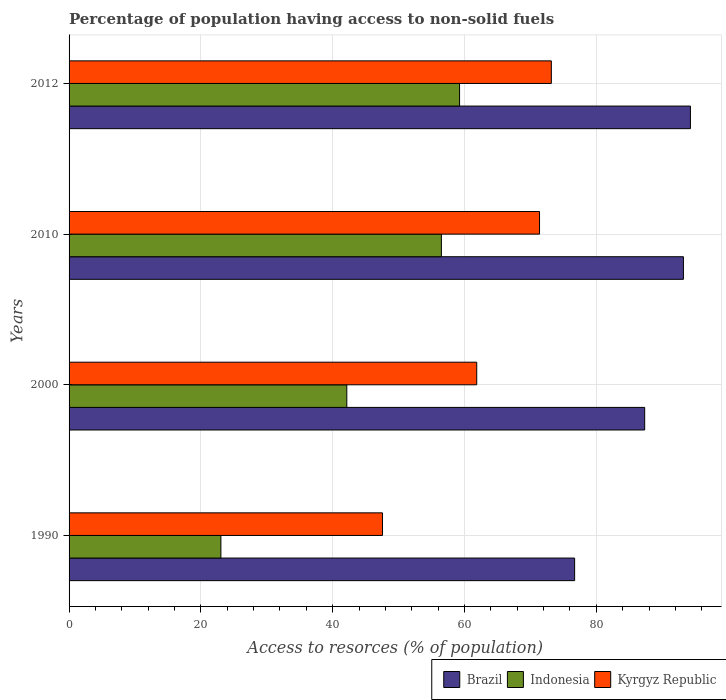Are the number of bars per tick equal to the number of legend labels?
Your response must be concise. Yes. How many bars are there on the 2nd tick from the top?
Give a very brief answer. 3. What is the percentage of population having access to non-solid fuels in Kyrgyz Republic in 1990?
Your answer should be compact. 47.55. Across all years, what is the maximum percentage of population having access to non-solid fuels in Brazil?
Keep it short and to the point. 94.28. Across all years, what is the minimum percentage of population having access to non-solid fuels in Brazil?
Keep it short and to the point. 76.71. In which year was the percentage of population having access to non-solid fuels in Kyrgyz Republic maximum?
Ensure brevity in your answer.  2012. What is the total percentage of population having access to non-solid fuels in Kyrgyz Republic in the graph?
Give a very brief answer. 253.97. What is the difference between the percentage of population having access to non-solid fuels in Brazil in 2000 and that in 2012?
Offer a terse response. -6.94. What is the difference between the percentage of population having access to non-solid fuels in Indonesia in 1990 and the percentage of population having access to non-solid fuels in Brazil in 2000?
Provide a succinct answer. -64.3. What is the average percentage of population having access to non-solid fuels in Indonesia per year?
Your answer should be compact. 45.23. In the year 1990, what is the difference between the percentage of population having access to non-solid fuels in Indonesia and percentage of population having access to non-solid fuels in Brazil?
Make the answer very short. -53.67. What is the ratio of the percentage of population having access to non-solid fuels in Kyrgyz Republic in 1990 to that in 2000?
Offer a very short reply. 0.77. What is the difference between the highest and the second highest percentage of population having access to non-solid fuels in Kyrgyz Republic?
Offer a very short reply. 1.79. What is the difference between the highest and the lowest percentage of population having access to non-solid fuels in Brazil?
Your answer should be very brief. 17.57. In how many years, is the percentage of population having access to non-solid fuels in Kyrgyz Republic greater than the average percentage of population having access to non-solid fuels in Kyrgyz Republic taken over all years?
Offer a very short reply. 2. What does the 3rd bar from the top in 2012 represents?
Offer a very short reply. Brazil. Is it the case that in every year, the sum of the percentage of population having access to non-solid fuels in Indonesia and percentage of population having access to non-solid fuels in Kyrgyz Republic is greater than the percentage of population having access to non-solid fuels in Brazil?
Keep it short and to the point. No. Are the values on the major ticks of X-axis written in scientific E-notation?
Your answer should be compact. No. Does the graph contain grids?
Your answer should be very brief. Yes. How many legend labels are there?
Keep it short and to the point. 3. How are the legend labels stacked?
Ensure brevity in your answer.  Horizontal. What is the title of the graph?
Provide a succinct answer. Percentage of population having access to non-solid fuels. Does "Canada" appear as one of the legend labels in the graph?
Your answer should be compact. No. What is the label or title of the X-axis?
Your response must be concise. Access to resorces (% of population). What is the Access to resorces (% of population) in Brazil in 1990?
Keep it short and to the point. 76.71. What is the Access to resorces (% of population) in Indonesia in 1990?
Ensure brevity in your answer.  23.04. What is the Access to resorces (% of population) in Kyrgyz Republic in 1990?
Your answer should be very brief. 47.55. What is the Access to resorces (% of population) in Brazil in 2000?
Your answer should be compact. 87.34. What is the Access to resorces (% of population) of Indonesia in 2000?
Your response must be concise. 42.14. What is the Access to resorces (% of population) of Kyrgyz Republic in 2000?
Your response must be concise. 61.85. What is the Access to resorces (% of population) of Brazil in 2010?
Ensure brevity in your answer.  93.22. What is the Access to resorces (% of population) of Indonesia in 2010?
Keep it short and to the point. 56.49. What is the Access to resorces (% of population) in Kyrgyz Republic in 2010?
Provide a succinct answer. 71.38. What is the Access to resorces (% of population) of Brazil in 2012?
Your answer should be compact. 94.28. What is the Access to resorces (% of population) in Indonesia in 2012?
Your response must be concise. 59.25. What is the Access to resorces (% of population) of Kyrgyz Republic in 2012?
Ensure brevity in your answer.  73.18. Across all years, what is the maximum Access to resorces (% of population) of Brazil?
Offer a very short reply. 94.28. Across all years, what is the maximum Access to resorces (% of population) in Indonesia?
Offer a terse response. 59.25. Across all years, what is the maximum Access to resorces (% of population) in Kyrgyz Republic?
Ensure brevity in your answer.  73.18. Across all years, what is the minimum Access to resorces (% of population) of Brazil?
Make the answer very short. 76.71. Across all years, what is the minimum Access to resorces (% of population) in Indonesia?
Provide a short and direct response. 23.04. Across all years, what is the minimum Access to resorces (% of population) in Kyrgyz Republic?
Make the answer very short. 47.55. What is the total Access to resorces (% of population) in Brazil in the graph?
Provide a short and direct response. 351.54. What is the total Access to resorces (% of population) in Indonesia in the graph?
Your answer should be very brief. 180.92. What is the total Access to resorces (% of population) of Kyrgyz Republic in the graph?
Your response must be concise. 253.97. What is the difference between the Access to resorces (% of population) of Brazil in 1990 and that in 2000?
Your answer should be compact. -10.63. What is the difference between the Access to resorces (% of population) in Indonesia in 1990 and that in 2000?
Your answer should be compact. -19.11. What is the difference between the Access to resorces (% of population) of Kyrgyz Republic in 1990 and that in 2000?
Provide a short and direct response. -14.3. What is the difference between the Access to resorces (% of population) in Brazil in 1990 and that in 2010?
Offer a very short reply. -16.51. What is the difference between the Access to resorces (% of population) of Indonesia in 1990 and that in 2010?
Offer a terse response. -33.46. What is the difference between the Access to resorces (% of population) of Kyrgyz Republic in 1990 and that in 2010?
Give a very brief answer. -23.83. What is the difference between the Access to resorces (% of population) in Brazil in 1990 and that in 2012?
Make the answer very short. -17.57. What is the difference between the Access to resorces (% of population) in Indonesia in 1990 and that in 2012?
Provide a short and direct response. -36.21. What is the difference between the Access to resorces (% of population) of Kyrgyz Republic in 1990 and that in 2012?
Give a very brief answer. -25.62. What is the difference between the Access to resorces (% of population) of Brazil in 2000 and that in 2010?
Your response must be concise. -5.88. What is the difference between the Access to resorces (% of population) in Indonesia in 2000 and that in 2010?
Give a very brief answer. -14.35. What is the difference between the Access to resorces (% of population) of Kyrgyz Republic in 2000 and that in 2010?
Your response must be concise. -9.53. What is the difference between the Access to resorces (% of population) of Brazil in 2000 and that in 2012?
Ensure brevity in your answer.  -6.94. What is the difference between the Access to resorces (% of population) of Indonesia in 2000 and that in 2012?
Provide a short and direct response. -17.11. What is the difference between the Access to resorces (% of population) in Kyrgyz Republic in 2000 and that in 2012?
Offer a very short reply. -11.32. What is the difference between the Access to resorces (% of population) of Brazil in 2010 and that in 2012?
Offer a terse response. -1.06. What is the difference between the Access to resorces (% of population) of Indonesia in 2010 and that in 2012?
Provide a short and direct response. -2.76. What is the difference between the Access to resorces (% of population) in Kyrgyz Republic in 2010 and that in 2012?
Give a very brief answer. -1.79. What is the difference between the Access to resorces (% of population) of Brazil in 1990 and the Access to resorces (% of population) of Indonesia in 2000?
Make the answer very short. 34.57. What is the difference between the Access to resorces (% of population) in Brazil in 1990 and the Access to resorces (% of population) in Kyrgyz Republic in 2000?
Give a very brief answer. 14.85. What is the difference between the Access to resorces (% of population) in Indonesia in 1990 and the Access to resorces (% of population) in Kyrgyz Republic in 2000?
Give a very brief answer. -38.82. What is the difference between the Access to resorces (% of population) of Brazil in 1990 and the Access to resorces (% of population) of Indonesia in 2010?
Offer a very short reply. 20.21. What is the difference between the Access to resorces (% of population) of Brazil in 1990 and the Access to resorces (% of population) of Kyrgyz Republic in 2010?
Offer a terse response. 5.32. What is the difference between the Access to resorces (% of population) of Indonesia in 1990 and the Access to resorces (% of population) of Kyrgyz Republic in 2010?
Offer a terse response. -48.35. What is the difference between the Access to resorces (% of population) in Brazil in 1990 and the Access to resorces (% of population) in Indonesia in 2012?
Keep it short and to the point. 17.46. What is the difference between the Access to resorces (% of population) of Brazil in 1990 and the Access to resorces (% of population) of Kyrgyz Republic in 2012?
Ensure brevity in your answer.  3.53. What is the difference between the Access to resorces (% of population) of Indonesia in 1990 and the Access to resorces (% of population) of Kyrgyz Republic in 2012?
Your answer should be very brief. -50.14. What is the difference between the Access to resorces (% of population) in Brazil in 2000 and the Access to resorces (% of population) in Indonesia in 2010?
Your response must be concise. 30.85. What is the difference between the Access to resorces (% of population) in Brazil in 2000 and the Access to resorces (% of population) in Kyrgyz Republic in 2010?
Keep it short and to the point. 15.96. What is the difference between the Access to resorces (% of population) in Indonesia in 2000 and the Access to resorces (% of population) in Kyrgyz Republic in 2010?
Keep it short and to the point. -29.24. What is the difference between the Access to resorces (% of population) of Brazil in 2000 and the Access to resorces (% of population) of Indonesia in 2012?
Give a very brief answer. 28.09. What is the difference between the Access to resorces (% of population) in Brazil in 2000 and the Access to resorces (% of population) in Kyrgyz Republic in 2012?
Your response must be concise. 14.16. What is the difference between the Access to resorces (% of population) of Indonesia in 2000 and the Access to resorces (% of population) of Kyrgyz Republic in 2012?
Make the answer very short. -31.03. What is the difference between the Access to resorces (% of population) in Brazil in 2010 and the Access to resorces (% of population) in Indonesia in 2012?
Your answer should be compact. 33.97. What is the difference between the Access to resorces (% of population) of Brazil in 2010 and the Access to resorces (% of population) of Kyrgyz Republic in 2012?
Offer a very short reply. 20.04. What is the difference between the Access to resorces (% of population) in Indonesia in 2010 and the Access to resorces (% of population) in Kyrgyz Republic in 2012?
Ensure brevity in your answer.  -16.68. What is the average Access to resorces (% of population) in Brazil per year?
Make the answer very short. 87.89. What is the average Access to resorces (% of population) in Indonesia per year?
Offer a very short reply. 45.23. What is the average Access to resorces (% of population) in Kyrgyz Republic per year?
Offer a terse response. 63.49. In the year 1990, what is the difference between the Access to resorces (% of population) in Brazil and Access to resorces (% of population) in Indonesia?
Provide a short and direct response. 53.67. In the year 1990, what is the difference between the Access to resorces (% of population) in Brazil and Access to resorces (% of population) in Kyrgyz Republic?
Provide a short and direct response. 29.15. In the year 1990, what is the difference between the Access to resorces (% of population) of Indonesia and Access to resorces (% of population) of Kyrgyz Republic?
Make the answer very short. -24.52. In the year 2000, what is the difference between the Access to resorces (% of population) in Brazil and Access to resorces (% of population) in Indonesia?
Offer a very short reply. 45.2. In the year 2000, what is the difference between the Access to resorces (% of population) in Brazil and Access to resorces (% of population) in Kyrgyz Republic?
Ensure brevity in your answer.  25.49. In the year 2000, what is the difference between the Access to resorces (% of population) of Indonesia and Access to resorces (% of population) of Kyrgyz Republic?
Your answer should be compact. -19.71. In the year 2010, what is the difference between the Access to resorces (% of population) of Brazil and Access to resorces (% of population) of Indonesia?
Your answer should be compact. 36.72. In the year 2010, what is the difference between the Access to resorces (% of population) in Brazil and Access to resorces (% of population) in Kyrgyz Republic?
Your response must be concise. 21.83. In the year 2010, what is the difference between the Access to resorces (% of population) of Indonesia and Access to resorces (% of population) of Kyrgyz Republic?
Keep it short and to the point. -14.89. In the year 2012, what is the difference between the Access to resorces (% of population) of Brazil and Access to resorces (% of population) of Indonesia?
Provide a succinct answer. 35.03. In the year 2012, what is the difference between the Access to resorces (% of population) in Brazil and Access to resorces (% of population) in Kyrgyz Republic?
Provide a succinct answer. 21.1. In the year 2012, what is the difference between the Access to resorces (% of population) in Indonesia and Access to resorces (% of population) in Kyrgyz Republic?
Offer a very short reply. -13.93. What is the ratio of the Access to resorces (% of population) in Brazil in 1990 to that in 2000?
Keep it short and to the point. 0.88. What is the ratio of the Access to resorces (% of population) in Indonesia in 1990 to that in 2000?
Your answer should be very brief. 0.55. What is the ratio of the Access to resorces (% of population) of Kyrgyz Republic in 1990 to that in 2000?
Offer a very short reply. 0.77. What is the ratio of the Access to resorces (% of population) of Brazil in 1990 to that in 2010?
Keep it short and to the point. 0.82. What is the ratio of the Access to resorces (% of population) in Indonesia in 1990 to that in 2010?
Your answer should be very brief. 0.41. What is the ratio of the Access to resorces (% of population) of Kyrgyz Republic in 1990 to that in 2010?
Keep it short and to the point. 0.67. What is the ratio of the Access to resorces (% of population) in Brazil in 1990 to that in 2012?
Your answer should be very brief. 0.81. What is the ratio of the Access to resorces (% of population) of Indonesia in 1990 to that in 2012?
Your answer should be very brief. 0.39. What is the ratio of the Access to resorces (% of population) of Kyrgyz Republic in 1990 to that in 2012?
Make the answer very short. 0.65. What is the ratio of the Access to resorces (% of population) in Brazil in 2000 to that in 2010?
Give a very brief answer. 0.94. What is the ratio of the Access to resorces (% of population) in Indonesia in 2000 to that in 2010?
Ensure brevity in your answer.  0.75. What is the ratio of the Access to resorces (% of population) in Kyrgyz Republic in 2000 to that in 2010?
Your answer should be compact. 0.87. What is the ratio of the Access to resorces (% of population) of Brazil in 2000 to that in 2012?
Provide a succinct answer. 0.93. What is the ratio of the Access to resorces (% of population) in Indonesia in 2000 to that in 2012?
Ensure brevity in your answer.  0.71. What is the ratio of the Access to resorces (% of population) in Kyrgyz Republic in 2000 to that in 2012?
Your response must be concise. 0.85. What is the ratio of the Access to resorces (% of population) in Brazil in 2010 to that in 2012?
Keep it short and to the point. 0.99. What is the ratio of the Access to resorces (% of population) of Indonesia in 2010 to that in 2012?
Your answer should be very brief. 0.95. What is the ratio of the Access to resorces (% of population) of Kyrgyz Republic in 2010 to that in 2012?
Offer a terse response. 0.98. What is the difference between the highest and the second highest Access to resorces (% of population) in Brazil?
Provide a short and direct response. 1.06. What is the difference between the highest and the second highest Access to resorces (% of population) in Indonesia?
Your answer should be compact. 2.76. What is the difference between the highest and the second highest Access to resorces (% of population) in Kyrgyz Republic?
Make the answer very short. 1.79. What is the difference between the highest and the lowest Access to resorces (% of population) in Brazil?
Offer a very short reply. 17.57. What is the difference between the highest and the lowest Access to resorces (% of population) of Indonesia?
Offer a very short reply. 36.21. What is the difference between the highest and the lowest Access to resorces (% of population) in Kyrgyz Republic?
Your answer should be compact. 25.62. 